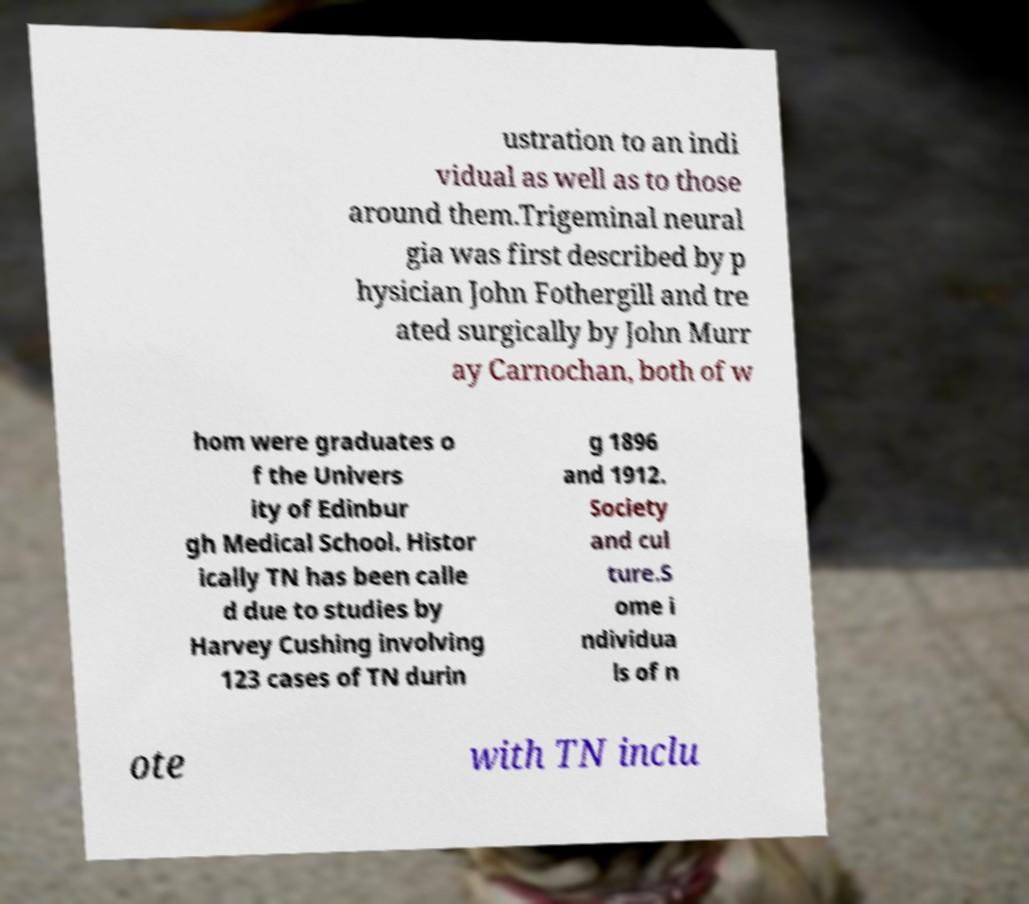What messages or text are displayed in this image? I need them in a readable, typed format. ustration to an indi vidual as well as to those around them.Trigeminal neural gia was first described by p hysician John Fothergill and tre ated surgically by John Murr ay Carnochan, both of w hom were graduates o f the Univers ity of Edinbur gh Medical School. Histor ically TN has been calle d due to studies by Harvey Cushing involving 123 cases of TN durin g 1896 and 1912. Society and cul ture.S ome i ndividua ls of n ote with TN inclu 